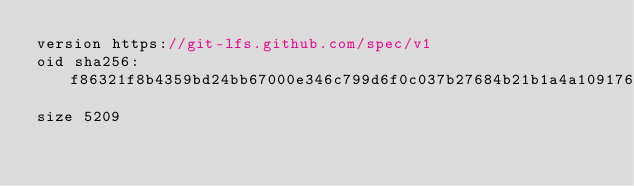Convert code to text. <code><loc_0><loc_0><loc_500><loc_500><_C++_>version https://git-lfs.github.com/spec/v1
oid sha256:f86321f8b4359bd24bb67000e346c799d6f0c037b27684b21b1a4a1091760ecb
size 5209
</code> 